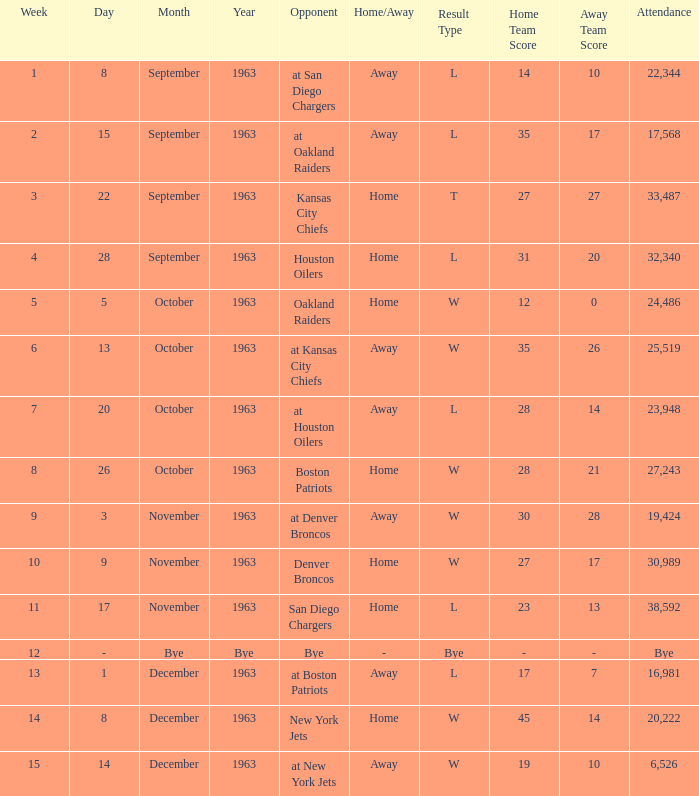Parse the table in full. {'header': ['Week', 'Day', 'Month', 'Year', 'Opponent', 'Home/Away', 'Result Type', 'Home Team Score', 'Away Team Score', 'Attendance'], 'rows': [['1', '8', 'September', '1963', 'at San Diego Chargers', 'Away', 'L', '14', '10', '22,344'], ['2', '15', 'September', '1963', 'at Oakland Raiders', 'Away', 'L', '35', '17', '17,568'], ['3', '22', 'September', '1963', 'Kansas City Chiefs', 'Home', 'T', '27', '27', '33,487'], ['4', '28', 'September', '1963', 'Houston Oilers', 'Home', 'L', '31', '20', '32,340'], ['5', '5', 'October', '1963', 'Oakland Raiders', 'Home', 'W', '12', '0', '24,486'], ['6', '13', 'October', '1963', 'at Kansas City Chiefs', 'Away', 'W', '35', '26', '25,519'], ['7', '20', 'October', '1963', 'at Houston Oilers', 'Away', 'L', '28', '14', '23,948'], ['8', '26', 'October', '1963', 'Boston Patriots', 'Home', 'W', '28', '21', '27,243'], ['9', '3', 'November', '1963', 'at Denver Broncos', 'Away', 'W', '30', '28', '19,424'], ['10', '9', 'November', '1963', 'Denver Broncos', 'Home', 'W', '27', '17', '30,989'], ['11', '17', 'November', '1963', 'San Diego Chargers', 'Home', 'L', '23', '13', '38,592'], ['12', '-', 'Bye', 'Bye', 'Bye', '-', 'Bye', '-', '-', 'Bye'], ['13', '1', 'December', '1963', 'at Boston Patriots', 'Away', 'L', '17', '7', '16,981'], ['14', '8', 'December', '1963', 'New York Jets', 'Home', 'W', '45', '14', '20,222'], ['15', '14', 'December', '1963', 'at New York Jets', 'Away', 'W', '19', '10', '6,526']]} Which Opponent has a Result of l 14–10? At san diego chargers. 